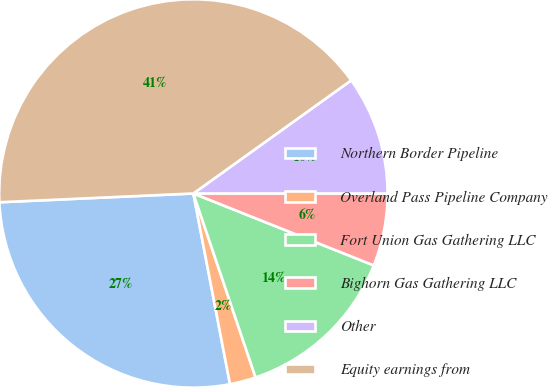Convert chart. <chart><loc_0><loc_0><loc_500><loc_500><pie_chart><fcel>Northern Border Pipeline<fcel>Overland Pass Pipeline Company<fcel>Fort Union Gas Gathering LLC<fcel>Bighorn Gas Gathering LLC<fcel>Other<fcel>Equity earnings from<nl><fcel>27.3%<fcel>2.17%<fcel>13.77%<fcel>6.04%<fcel>9.9%<fcel>40.82%<nl></chart> 